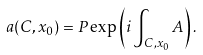<formula> <loc_0><loc_0><loc_500><loc_500>a ( C , x _ { 0 } ) = P \exp \left ( i \int _ { C , x _ { 0 } } A \right ) .</formula> 